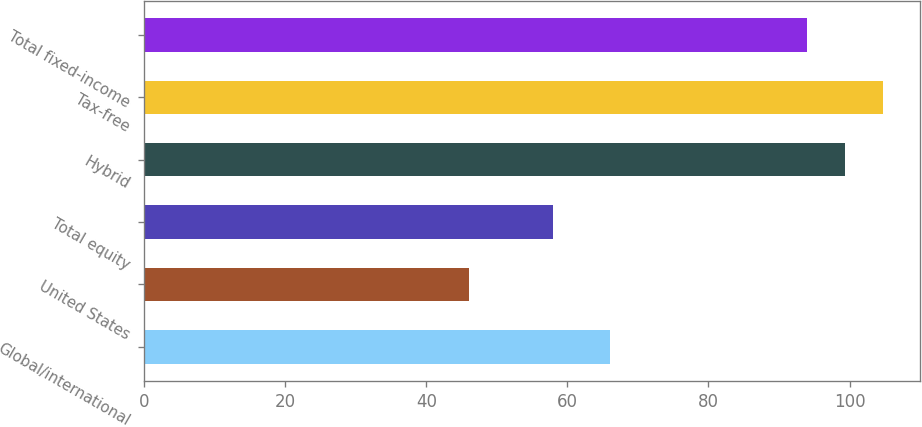<chart> <loc_0><loc_0><loc_500><loc_500><bar_chart><fcel>Global/international<fcel>United States<fcel>Total equity<fcel>Hybrid<fcel>Tax-free<fcel>Total fixed-income<nl><fcel>66<fcel>46<fcel>58<fcel>99.4<fcel>104.8<fcel>94<nl></chart> 